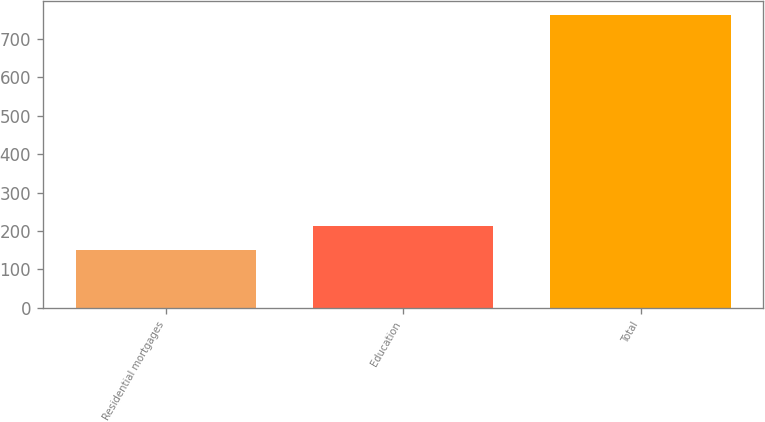<chart> <loc_0><loc_0><loc_500><loc_500><bar_chart><fcel>Residential mortgages<fcel>Education<fcel>Total<nl><fcel>151<fcel>212<fcel>761<nl></chart> 